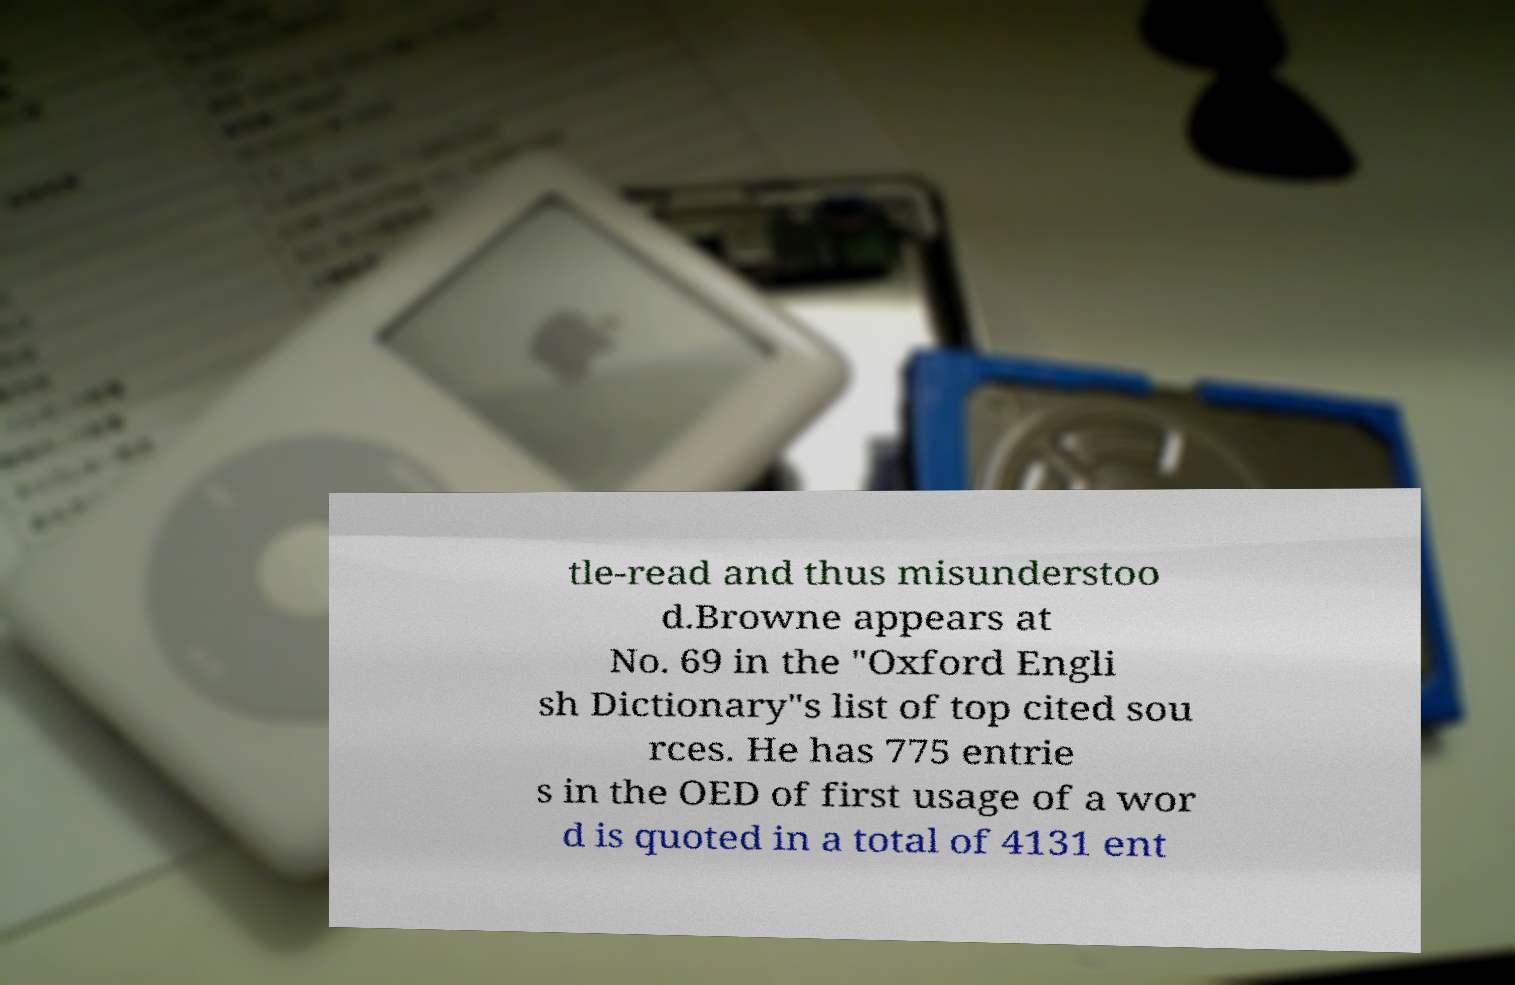Can you read and provide the text displayed in the image?This photo seems to have some interesting text. Can you extract and type it out for me? tle-read and thus misunderstoo d.Browne appears at No. 69 in the "Oxford Engli sh Dictionary"s list of top cited sou rces. He has 775 entrie s in the OED of first usage of a wor d is quoted in a total of 4131 ent 